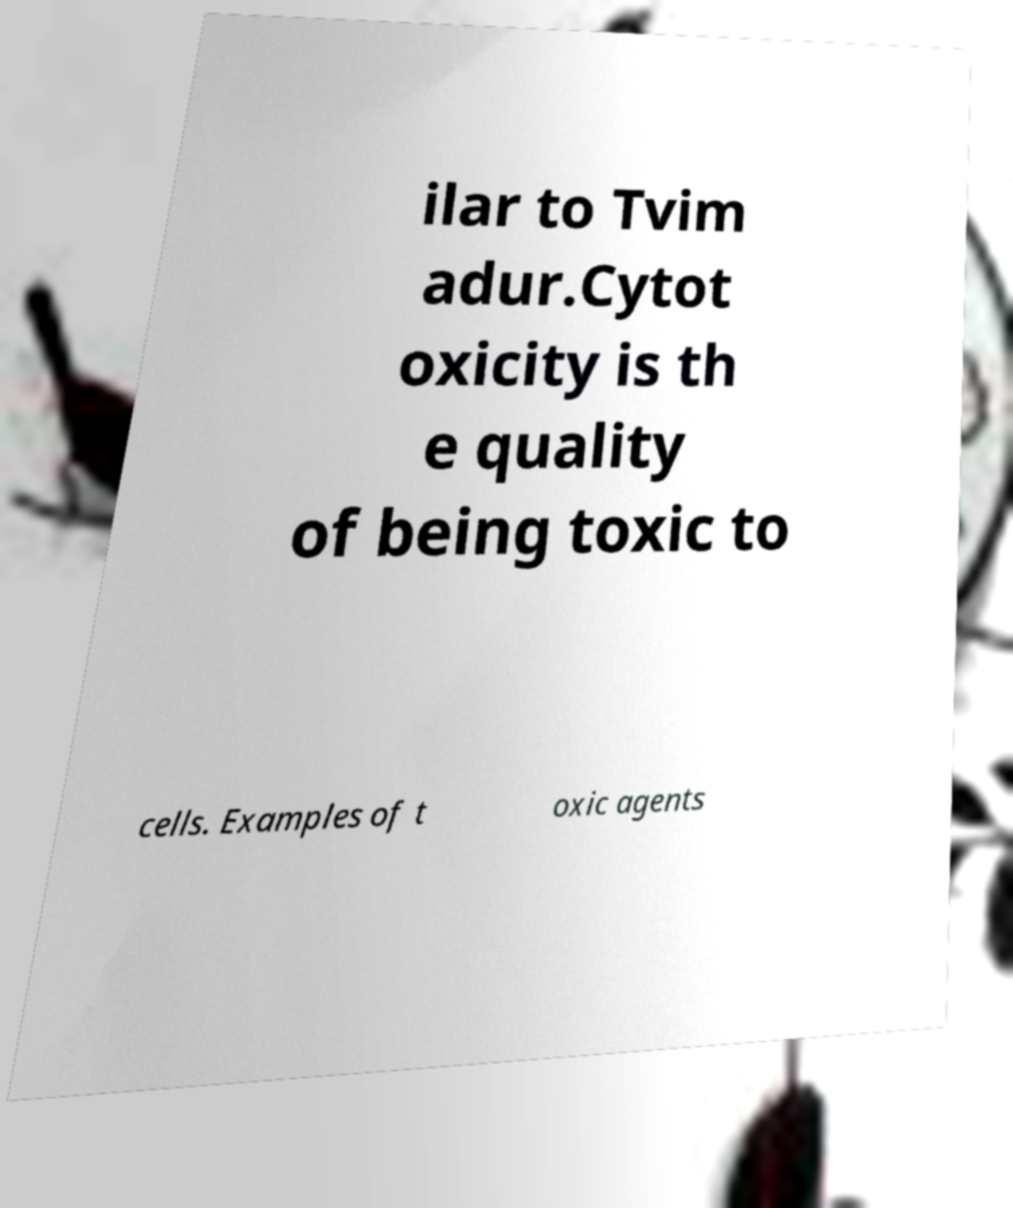For documentation purposes, I need the text within this image transcribed. Could you provide that? ilar to Tvim adur.Cytot oxicity is th e quality of being toxic to cells. Examples of t oxic agents 